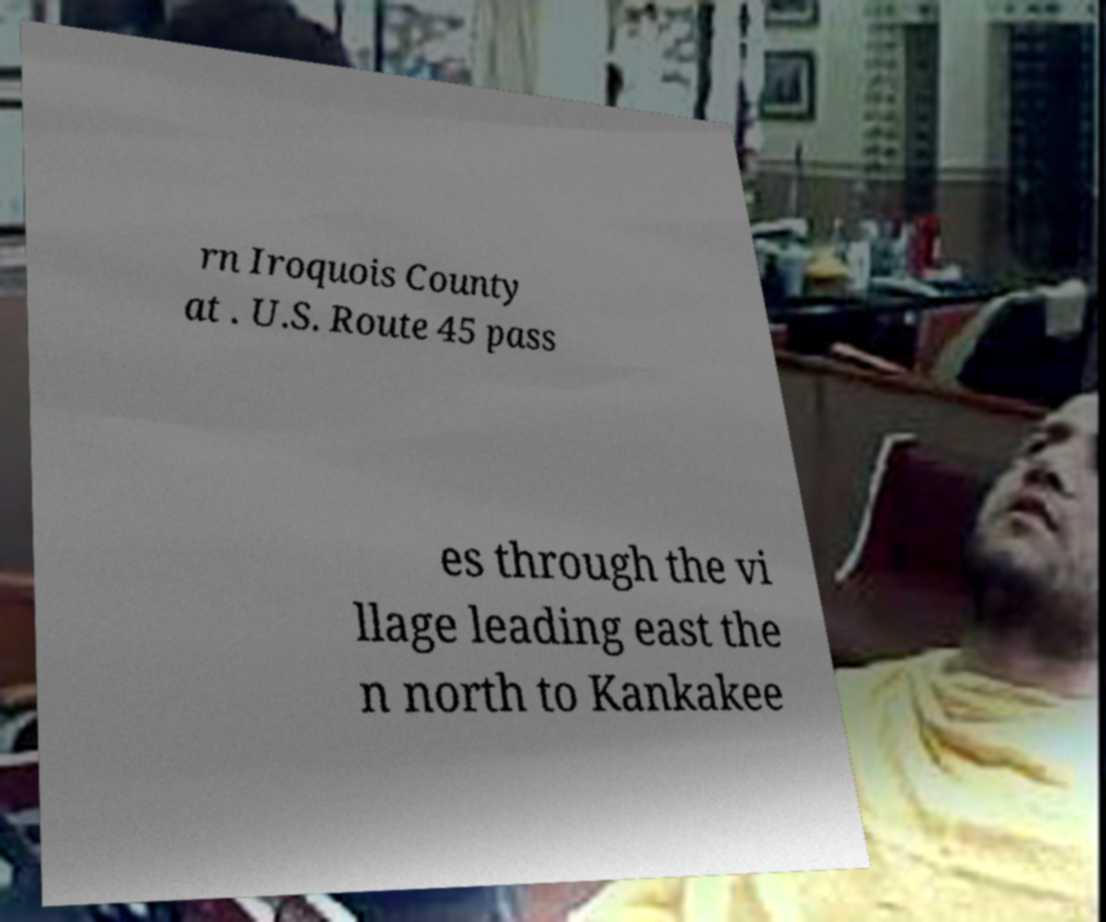There's text embedded in this image that I need extracted. Can you transcribe it verbatim? rn Iroquois County at . U.S. Route 45 pass es through the vi llage leading east the n north to Kankakee 